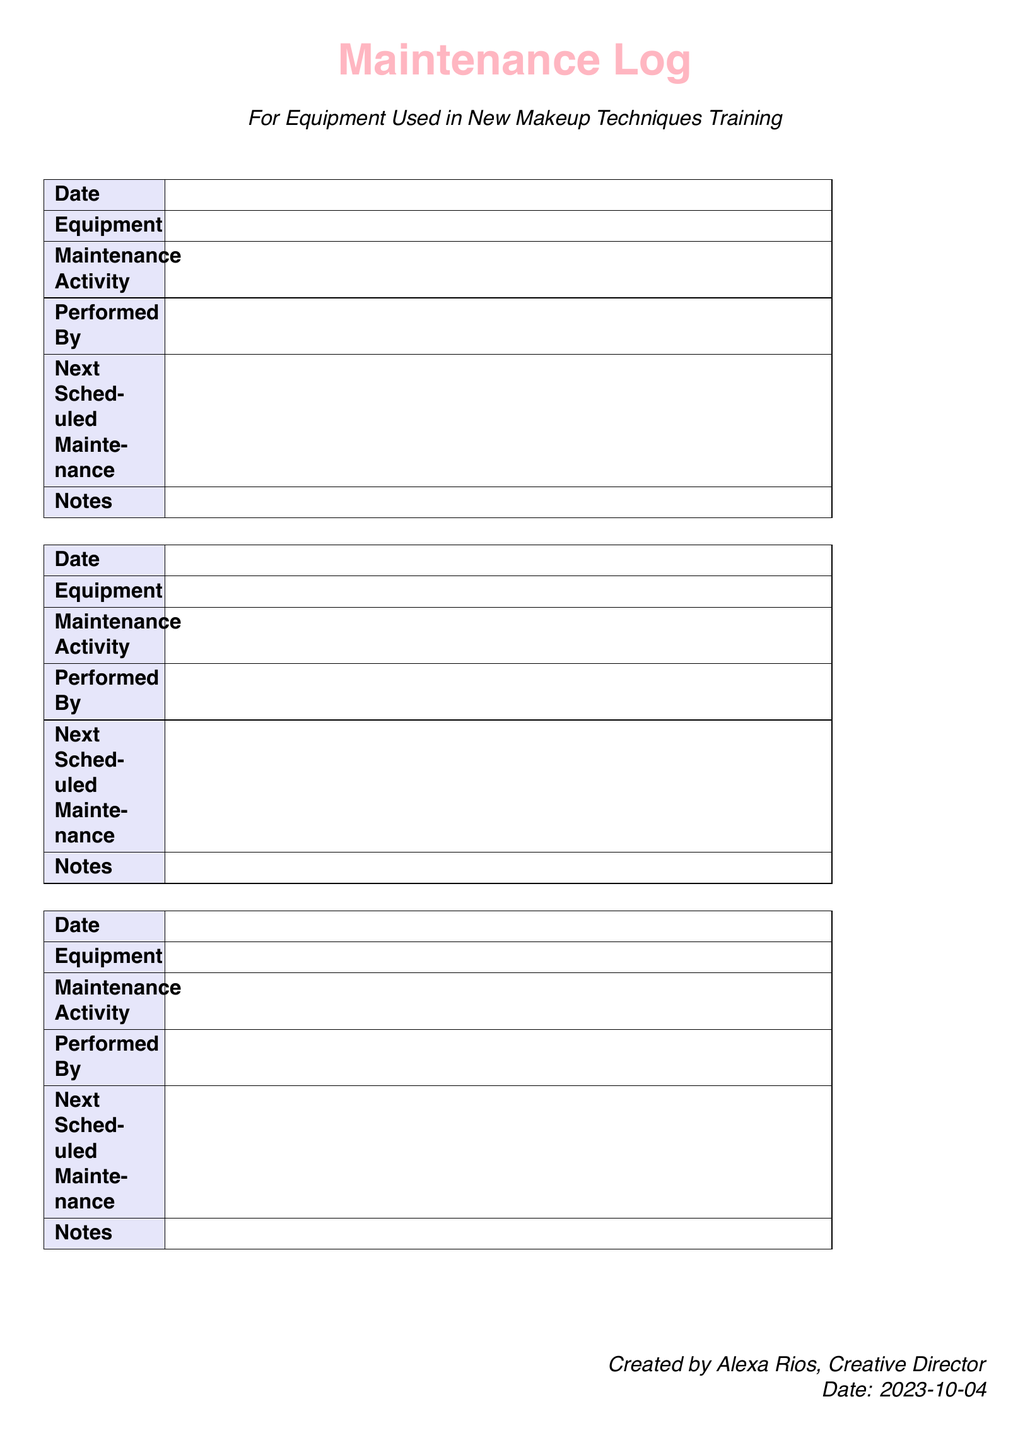What is the title of the document? The title is presented at the top of the document, indicated as "Maintenance Log."
Answer: Maintenance Log Who created the document? The creator of the document is mentioned in the footer section as "Alexa Rios, Creative Director."
Answer: Alexa Rios What color is used for the header section? The header section color is defined in the document using the RGB code for "beautypink."
Answer: beautypink What date was the document created? The creation date is noted in the footer, showing the specific date of creation.
Answer: 2023-10-04 How many maintenance logs are listed in the document? The document contains three separate maintenance log entries formatted in tables.
Answer: 3 What information is required in the "Next Scheduled Maintenance" field? The field requires the next scheduled maintenance date for the equipment.
Answer: Date What type of maintenance log is this? This log specifically pertains to equipment used in training sessions for new makeup techniques.
Answer: Equipment used in New Makeup Techniques Training What is the total number of maintenance activity types listed in the document? Each maintenance log entry has a dedicated space for "Maintenance Activity," leading to a total of three entries.
Answer: 3 Who performed the maintenance activities? The document structure includes a section for noting who performed the maintenance, but does not specify names.
Answer: Performed By 